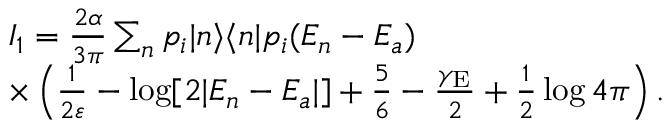<formula> <loc_0><loc_0><loc_500><loc_500>\begin{array} { r l } & { I _ { 1 } = \frac { 2 \alpha } { 3 \pi } \sum _ { n } p _ { i } | n \rangle \langle n | p _ { i } ( E _ { n } - E _ { a } ) } \\ & { \times \left ( \frac { 1 } { 2 \varepsilon } - \log [ 2 | E _ { n } - E _ { a } | ] + \frac { 5 } { 6 } - \frac { \gamma _ { E } } { 2 } + \frac { 1 } { 2 } \log 4 \pi \right ) . } \end{array}</formula> 